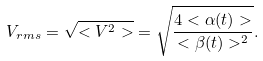Convert formula to latex. <formula><loc_0><loc_0><loc_500><loc_500>V _ { r m s } = \sqrt { < V ^ { 2 } > } = \sqrt { \frac { 4 < \alpha ( t ) > } { < \beta ( t ) > ^ { 2 } } } .</formula> 